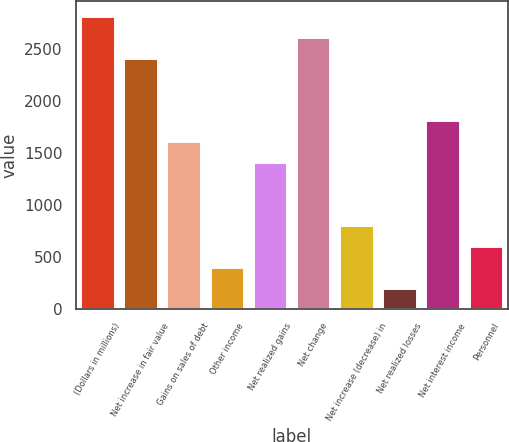Convert chart to OTSL. <chart><loc_0><loc_0><loc_500><loc_500><bar_chart><fcel>(Dollars in millions)<fcel>Net increase in fair value<fcel>Gains on sales of debt<fcel>Other income<fcel>Net realized gains<fcel>Net change<fcel>Net increase (decrease) in<fcel>Net realized losses<fcel>Net interest income<fcel>Personnel<nl><fcel>2821.6<fcel>2418.8<fcel>1613.2<fcel>404.8<fcel>1411.8<fcel>2620.2<fcel>807.6<fcel>203.4<fcel>1814.6<fcel>606.2<nl></chart> 